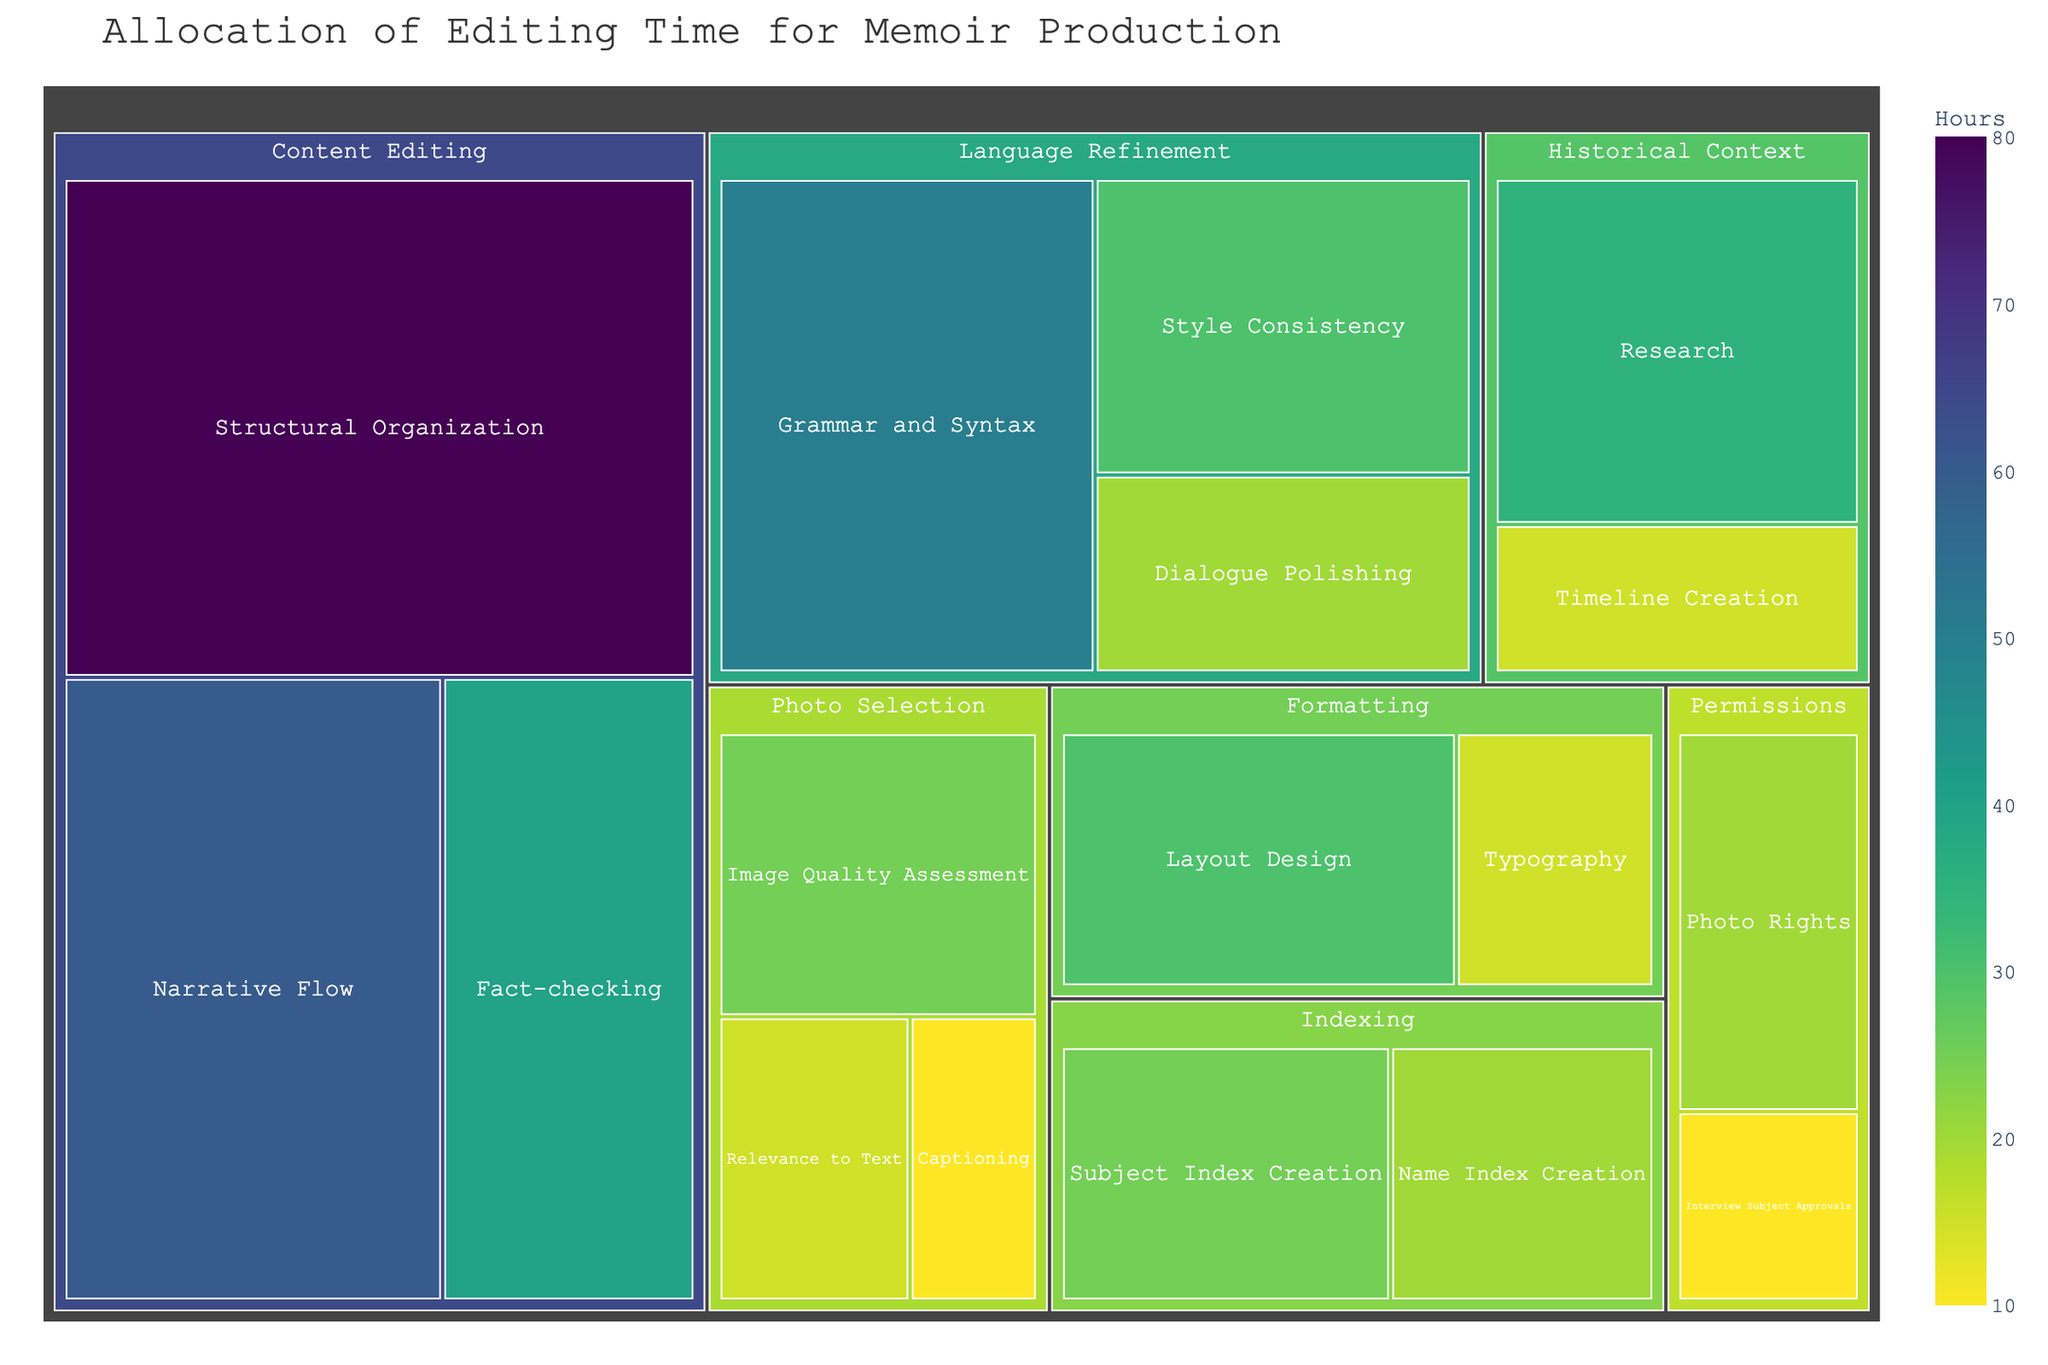What's the title of the treemap? The title of the treemap is shown at the top of the figure.
Answer: Allocation of Editing Time for Memoir Production Which subcategory has the highest number of hours under 'Content Editing'? By looking at the 'Content Editing' category, compare the hours for each subcategory: Structural Organization (80), Narrative Flow (60), and Fact-checking (40). The highest is Structural Organization.
Answer: Structural Organization How many total hours are spent on 'Language Refinement'? Add the hours for all subcategories under 'Language Refinement': Grammar and Syntax (50), Style Consistency (30), and Dialogue Polishing (20). 50 + 30 + 20 = 100.
Answer: 100 What is the difference in hours between 'Research' and 'Timeline Creation' under 'Historical Context'? Find the hours listed for 'Research' (35) and 'Timeline Creation' (15) under 'Historical Context' and calculate the difference: 35 - 15 = 20.
Answer: 20 Which category has the highest number of subcategories? Count the subcategories under each category by looking at how many rectangles fall under each main category in the treemap: Content Editing (3), Language Refinement (3), Photo Selection (3), Historical Context (2), Permissions (2), Formatting (2), Indexing (2). Multiple categories have an equal highest number (3).
Answer: Content Editing, Language Refinement, Photo Selection Which subcategory in 'Indexing' requires more hours, and by how much compared to the other subcategory? Compare the hours for 'Subject Index Creation' (25) and 'Name Index Creation' (20) in 'Indexing'. Subject Index Creation requires 5 more hours than Name Index Creation.
Answer: Subject Index Creation, 5 What is the total number of categories in this treemap? Count the unique main categories in the treemap: Content Editing, Language Refinement, Photo Selection, Historical Context, Permissions, Formatting, Indexing. There are 7 categories.
Answer: 7 Which subcategory spends an equal amount of hours as 'Timeline Creation' in 'Historical Context'? Look for other subcategories with 15 hours. 'Relevance to Text' under 'Photo Selection’ and 'Typography' under 'Formatting’ also have 15 hours each.
Answer: Relevance to Text, Typography 